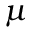<formula> <loc_0><loc_0><loc_500><loc_500>\mu</formula> 